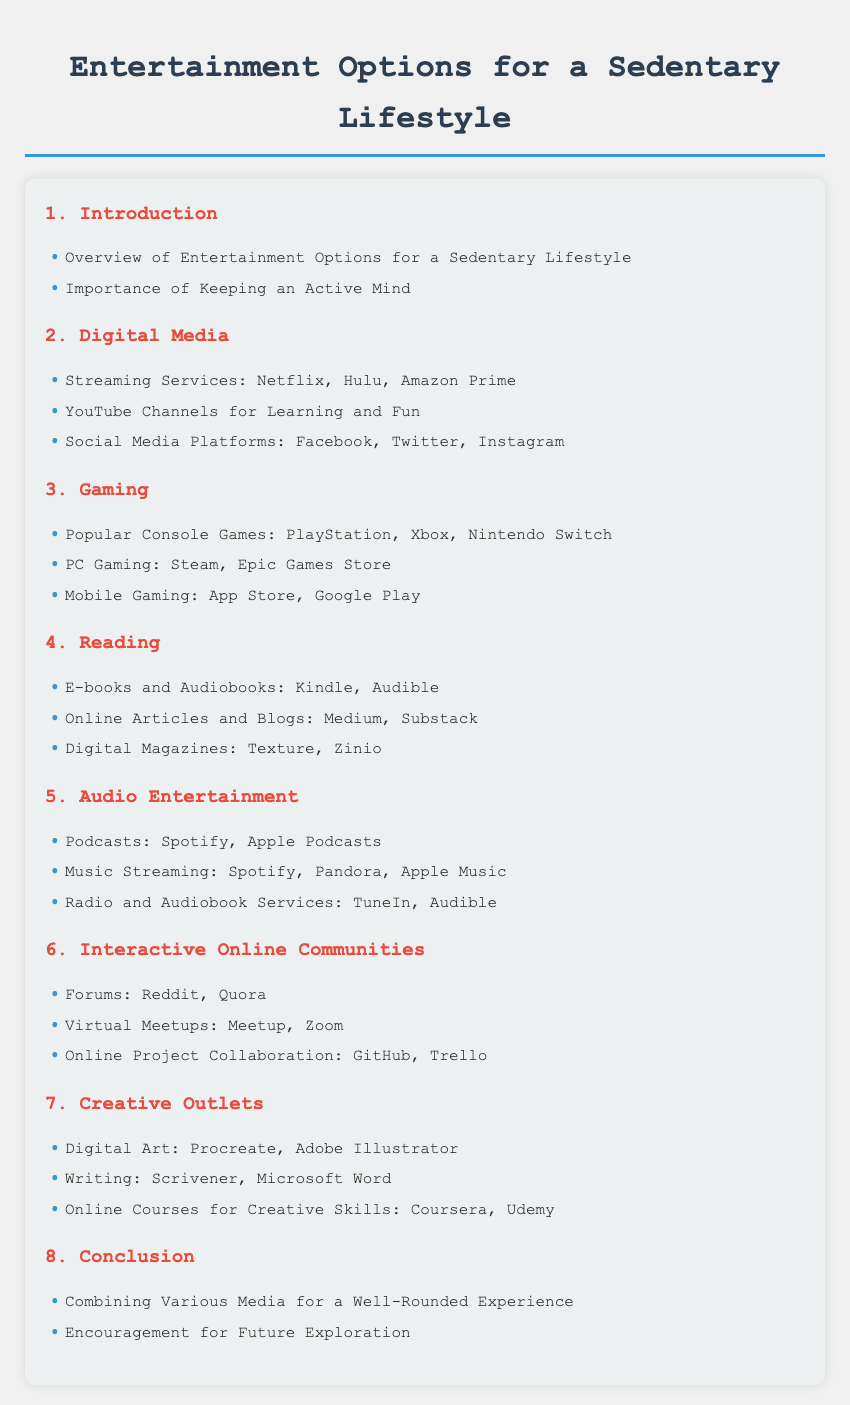What is the title of the document? The title of the document is mentioned at the top of the rendered HTML, which is "Entertainment Options for a Sedentary Lifestyle."
Answer: Entertainment Options for a Sedentary Lifestyle How many chapters are there in the document? The total number of chapters is counted by looking at the headings in the Table of Contents, which shows 8 chapters.
Answer: 8 What is covered in Chapter 2? Chapter 2 is focused on "Digital Media" and contains a list of digital entertainment options.
Answer: Digital Media Which streaming services are mentioned in the document? The document lists streaming services under Chapter 2, specifically mentioning Netflix, Hulu, and Amazon Prime.
Answer: Netflix, Hulu, Amazon Prime What is one type of reading option discussed? The document lists various types of reading options, one of which includes e-books and audiobooks, specifically Kindle and Audible.
Answer: E-books and Audiobooks Which online course platforms for creative skills are recommended? Chapter 7 covers creative outlets, mentioning online course platforms such as Coursera and Udemy.
Answer: Coursera, Udemy Name one social media platform listed in the document. Chapter 2 includes social media platforms, with Facebook being one of the examples provided.
Answer: Facebook What unique feature is included in the section items of the Table of Contents? Each section item in the Table of Contents has a bullet point feature before the item name, which visually distinguishes them.
Answer: Bullet points 